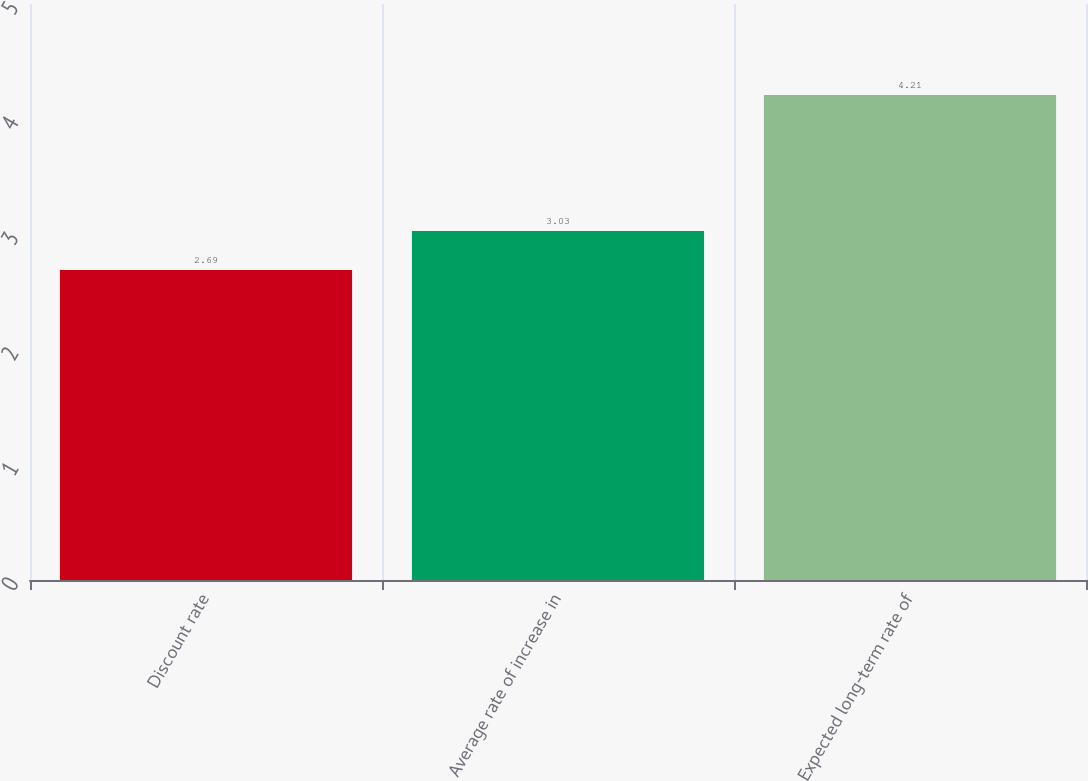<chart> <loc_0><loc_0><loc_500><loc_500><bar_chart><fcel>Discount rate<fcel>Average rate of increase in<fcel>Expected long-term rate of<nl><fcel>2.69<fcel>3.03<fcel>4.21<nl></chart> 